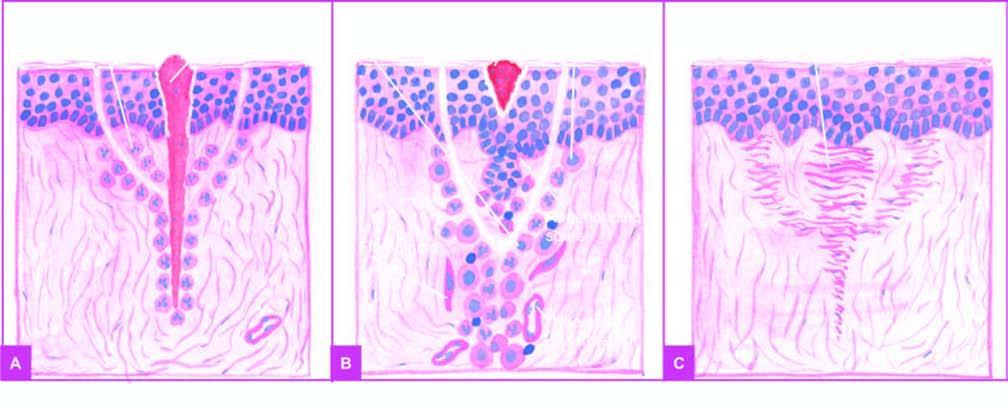what are the incised wound as well as suture track on either side filled with?
Answer the question using a single word or phrase. Blood clot 